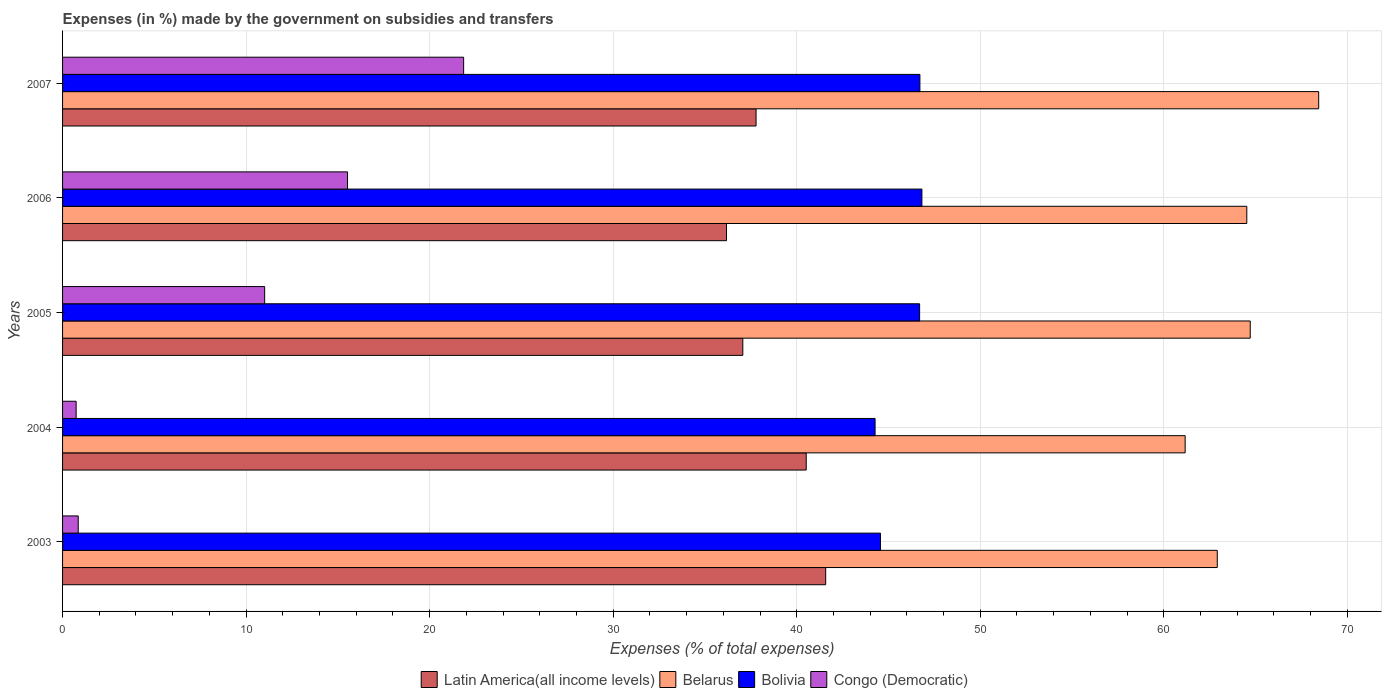How many different coloured bars are there?
Your answer should be compact. 4. How many groups of bars are there?
Your answer should be compact. 5. Are the number of bars on each tick of the Y-axis equal?
Keep it short and to the point. Yes. In how many cases, is the number of bars for a given year not equal to the number of legend labels?
Ensure brevity in your answer.  0. What is the percentage of expenses made by the government on subsidies and transfers in Bolivia in 2005?
Provide a short and direct response. 46.7. Across all years, what is the maximum percentage of expenses made by the government on subsidies and transfers in Bolivia?
Make the answer very short. 46.82. Across all years, what is the minimum percentage of expenses made by the government on subsidies and transfers in Belarus?
Keep it short and to the point. 61.16. In which year was the percentage of expenses made by the government on subsidies and transfers in Congo (Democratic) minimum?
Provide a succinct answer. 2004. What is the total percentage of expenses made by the government on subsidies and transfers in Congo (Democratic) in the graph?
Keep it short and to the point. 49.98. What is the difference between the percentage of expenses made by the government on subsidies and transfers in Congo (Democratic) in 2004 and that in 2006?
Make the answer very short. -14.79. What is the difference between the percentage of expenses made by the government on subsidies and transfers in Belarus in 2006 and the percentage of expenses made by the government on subsidies and transfers in Bolivia in 2003?
Make the answer very short. 19.96. What is the average percentage of expenses made by the government on subsidies and transfers in Belarus per year?
Keep it short and to the point. 64.35. In the year 2003, what is the difference between the percentage of expenses made by the government on subsidies and transfers in Bolivia and percentage of expenses made by the government on subsidies and transfers in Belarus?
Provide a succinct answer. -18.35. In how many years, is the percentage of expenses made by the government on subsidies and transfers in Bolivia greater than 44 %?
Provide a short and direct response. 5. What is the ratio of the percentage of expenses made by the government on subsidies and transfers in Latin America(all income levels) in 2003 to that in 2007?
Give a very brief answer. 1.1. Is the difference between the percentage of expenses made by the government on subsidies and transfers in Bolivia in 2005 and 2006 greater than the difference between the percentage of expenses made by the government on subsidies and transfers in Belarus in 2005 and 2006?
Your answer should be very brief. No. What is the difference between the highest and the second highest percentage of expenses made by the government on subsidies and transfers in Belarus?
Your response must be concise. 3.73. What is the difference between the highest and the lowest percentage of expenses made by the government on subsidies and transfers in Belarus?
Keep it short and to the point. 7.27. In how many years, is the percentage of expenses made by the government on subsidies and transfers in Congo (Democratic) greater than the average percentage of expenses made by the government on subsidies and transfers in Congo (Democratic) taken over all years?
Offer a terse response. 3. Is the sum of the percentage of expenses made by the government on subsidies and transfers in Congo (Democratic) in 2003 and 2007 greater than the maximum percentage of expenses made by the government on subsidies and transfers in Bolivia across all years?
Keep it short and to the point. No. Is it the case that in every year, the sum of the percentage of expenses made by the government on subsidies and transfers in Bolivia and percentage of expenses made by the government on subsidies and transfers in Belarus is greater than the sum of percentage of expenses made by the government on subsidies and transfers in Congo (Democratic) and percentage of expenses made by the government on subsidies and transfers in Latin America(all income levels)?
Offer a very short reply. No. What does the 3rd bar from the bottom in 2007 represents?
Provide a succinct answer. Bolivia. Is it the case that in every year, the sum of the percentage of expenses made by the government on subsidies and transfers in Latin America(all income levels) and percentage of expenses made by the government on subsidies and transfers in Congo (Democratic) is greater than the percentage of expenses made by the government on subsidies and transfers in Bolivia?
Your response must be concise. No. Are the values on the major ticks of X-axis written in scientific E-notation?
Keep it short and to the point. No. Does the graph contain any zero values?
Ensure brevity in your answer.  No. Does the graph contain grids?
Your response must be concise. Yes. Where does the legend appear in the graph?
Provide a short and direct response. Bottom center. How are the legend labels stacked?
Keep it short and to the point. Horizontal. What is the title of the graph?
Make the answer very short. Expenses (in %) made by the government on subsidies and transfers. What is the label or title of the X-axis?
Provide a short and direct response. Expenses (% of total expenses). What is the Expenses (% of total expenses) of Latin America(all income levels) in 2003?
Make the answer very short. 41.58. What is the Expenses (% of total expenses) of Belarus in 2003?
Keep it short and to the point. 62.91. What is the Expenses (% of total expenses) in Bolivia in 2003?
Give a very brief answer. 44.56. What is the Expenses (% of total expenses) of Congo (Democratic) in 2003?
Ensure brevity in your answer.  0.85. What is the Expenses (% of total expenses) in Latin America(all income levels) in 2004?
Your answer should be compact. 40.52. What is the Expenses (% of total expenses) in Belarus in 2004?
Your answer should be compact. 61.16. What is the Expenses (% of total expenses) of Bolivia in 2004?
Offer a terse response. 44.27. What is the Expenses (% of total expenses) in Congo (Democratic) in 2004?
Make the answer very short. 0.74. What is the Expenses (% of total expenses) of Latin America(all income levels) in 2005?
Make the answer very short. 37.06. What is the Expenses (% of total expenses) of Belarus in 2005?
Ensure brevity in your answer.  64.71. What is the Expenses (% of total expenses) in Bolivia in 2005?
Offer a terse response. 46.7. What is the Expenses (% of total expenses) in Congo (Democratic) in 2005?
Offer a very short reply. 11.01. What is the Expenses (% of total expenses) in Latin America(all income levels) in 2006?
Your answer should be very brief. 36.17. What is the Expenses (% of total expenses) of Belarus in 2006?
Make the answer very short. 64.52. What is the Expenses (% of total expenses) of Bolivia in 2006?
Offer a terse response. 46.82. What is the Expenses (% of total expenses) of Congo (Democratic) in 2006?
Ensure brevity in your answer.  15.53. What is the Expenses (% of total expenses) in Latin America(all income levels) in 2007?
Provide a succinct answer. 37.79. What is the Expenses (% of total expenses) of Belarus in 2007?
Offer a terse response. 68.44. What is the Expenses (% of total expenses) in Bolivia in 2007?
Give a very brief answer. 46.71. What is the Expenses (% of total expenses) of Congo (Democratic) in 2007?
Your answer should be very brief. 21.85. Across all years, what is the maximum Expenses (% of total expenses) in Latin America(all income levels)?
Provide a succinct answer. 41.58. Across all years, what is the maximum Expenses (% of total expenses) in Belarus?
Keep it short and to the point. 68.44. Across all years, what is the maximum Expenses (% of total expenses) in Bolivia?
Your answer should be very brief. 46.82. Across all years, what is the maximum Expenses (% of total expenses) of Congo (Democratic)?
Provide a short and direct response. 21.85. Across all years, what is the minimum Expenses (% of total expenses) of Latin America(all income levels)?
Provide a short and direct response. 36.17. Across all years, what is the minimum Expenses (% of total expenses) in Belarus?
Your answer should be very brief. 61.16. Across all years, what is the minimum Expenses (% of total expenses) of Bolivia?
Give a very brief answer. 44.27. Across all years, what is the minimum Expenses (% of total expenses) in Congo (Democratic)?
Your answer should be very brief. 0.74. What is the total Expenses (% of total expenses) in Latin America(all income levels) in the graph?
Give a very brief answer. 193.12. What is the total Expenses (% of total expenses) in Belarus in the graph?
Offer a very short reply. 321.75. What is the total Expenses (% of total expenses) in Bolivia in the graph?
Provide a short and direct response. 229.06. What is the total Expenses (% of total expenses) in Congo (Democratic) in the graph?
Offer a terse response. 49.98. What is the difference between the Expenses (% of total expenses) in Latin America(all income levels) in 2003 and that in 2004?
Give a very brief answer. 1.06. What is the difference between the Expenses (% of total expenses) of Belarus in 2003 and that in 2004?
Offer a terse response. 1.75. What is the difference between the Expenses (% of total expenses) of Bolivia in 2003 and that in 2004?
Your answer should be compact. 0.29. What is the difference between the Expenses (% of total expenses) of Congo (Democratic) in 2003 and that in 2004?
Offer a very short reply. 0.11. What is the difference between the Expenses (% of total expenses) in Latin America(all income levels) in 2003 and that in 2005?
Provide a succinct answer. 4.52. What is the difference between the Expenses (% of total expenses) in Belarus in 2003 and that in 2005?
Keep it short and to the point. -1.8. What is the difference between the Expenses (% of total expenses) of Bolivia in 2003 and that in 2005?
Make the answer very short. -2.13. What is the difference between the Expenses (% of total expenses) in Congo (Democratic) in 2003 and that in 2005?
Ensure brevity in your answer.  -10.16. What is the difference between the Expenses (% of total expenses) of Latin America(all income levels) in 2003 and that in 2006?
Your answer should be compact. 5.4. What is the difference between the Expenses (% of total expenses) of Belarus in 2003 and that in 2006?
Provide a short and direct response. -1.61. What is the difference between the Expenses (% of total expenses) in Bolivia in 2003 and that in 2006?
Give a very brief answer. -2.26. What is the difference between the Expenses (% of total expenses) of Congo (Democratic) in 2003 and that in 2006?
Keep it short and to the point. -14.67. What is the difference between the Expenses (% of total expenses) of Latin America(all income levels) in 2003 and that in 2007?
Your answer should be very brief. 3.79. What is the difference between the Expenses (% of total expenses) of Belarus in 2003 and that in 2007?
Provide a succinct answer. -5.52. What is the difference between the Expenses (% of total expenses) of Bolivia in 2003 and that in 2007?
Give a very brief answer. -2.15. What is the difference between the Expenses (% of total expenses) in Congo (Democratic) in 2003 and that in 2007?
Keep it short and to the point. -21. What is the difference between the Expenses (% of total expenses) of Latin America(all income levels) in 2004 and that in 2005?
Provide a succinct answer. 3.46. What is the difference between the Expenses (% of total expenses) of Belarus in 2004 and that in 2005?
Offer a very short reply. -3.55. What is the difference between the Expenses (% of total expenses) in Bolivia in 2004 and that in 2005?
Make the answer very short. -2.43. What is the difference between the Expenses (% of total expenses) in Congo (Democratic) in 2004 and that in 2005?
Provide a succinct answer. -10.27. What is the difference between the Expenses (% of total expenses) in Latin America(all income levels) in 2004 and that in 2006?
Ensure brevity in your answer.  4.34. What is the difference between the Expenses (% of total expenses) in Belarus in 2004 and that in 2006?
Give a very brief answer. -3.36. What is the difference between the Expenses (% of total expenses) in Bolivia in 2004 and that in 2006?
Your response must be concise. -2.55. What is the difference between the Expenses (% of total expenses) in Congo (Democratic) in 2004 and that in 2006?
Give a very brief answer. -14.79. What is the difference between the Expenses (% of total expenses) of Latin America(all income levels) in 2004 and that in 2007?
Keep it short and to the point. 2.73. What is the difference between the Expenses (% of total expenses) in Belarus in 2004 and that in 2007?
Your answer should be very brief. -7.28. What is the difference between the Expenses (% of total expenses) in Bolivia in 2004 and that in 2007?
Keep it short and to the point. -2.44. What is the difference between the Expenses (% of total expenses) of Congo (Democratic) in 2004 and that in 2007?
Your answer should be very brief. -21.11. What is the difference between the Expenses (% of total expenses) of Latin America(all income levels) in 2005 and that in 2006?
Offer a very short reply. 0.89. What is the difference between the Expenses (% of total expenses) of Belarus in 2005 and that in 2006?
Keep it short and to the point. 0.19. What is the difference between the Expenses (% of total expenses) of Bolivia in 2005 and that in 2006?
Provide a succinct answer. -0.12. What is the difference between the Expenses (% of total expenses) in Congo (Democratic) in 2005 and that in 2006?
Your response must be concise. -4.51. What is the difference between the Expenses (% of total expenses) in Latin America(all income levels) in 2005 and that in 2007?
Your answer should be very brief. -0.72. What is the difference between the Expenses (% of total expenses) in Belarus in 2005 and that in 2007?
Provide a short and direct response. -3.73. What is the difference between the Expenses (% of total expenses) in Bolivia in 2005 and that in 2007?
Your answer should be compact. -0.02. What is the difference between the Expenses (% of total expenses) of Congo (Democratic) in 2005 and that in 2007?
Your answer should be very brief. -10.84. What is the difference between the Expenses (% of total expenses) of Latin America(all income levels) in 2006 and that in 2007?
Your answer should be compact. -1.61. What is the difference between the Expenses (% of total expenses) in Belarus in 2006 and that in 2007?
Keep it short and to the point. -3.92. What is the difference between the Expenses (% of total expenses) of Bolivia in 2006 and that in 2007?
Give a very brief answer. 0.11. What is the difference between the Expenses (% of total expenses) in Congo (Democratic) in 2006 and that in 2007?
Your answer should be very brief. -6.33. What is the difference between the Expenses (% of total expenses) of Latin America(all income levels) in 2003 and the Expenses (% of total expenses) of Belarus in 2004?
Your response must be concise. -19.59. What is the difference between the Expenses (% of total expenses) in Latin America(all income levels) in 2003 and the Expenses (% of total expenses) in Bolivia in 2004?
Offer a very short reply. -2.69. What is the difference between the Expenses (% of total expenses) in Latin America(all income levels) in 2003 and the Expenses (% of total expenses) in Congo (Democratic) in 2004?
Your answer should be very brief. 40.84. What is the difference between the Expenses (% of total expenses) in Belarus in 2003 and the Expenses (% of total expenses) in Bolivia in 2004?
Ensure brevity in your answer.  18.65. What is the difference between the Expenses (% of total expenses) of Belarus in 2003 and the Expenses (% of total expenses) of Congo (Democratic) in 2004?
Keep it short and to the point. 62.17. What is the difference between the Expenses (% of total expenses) of Bolivia in 2003 and the Expenses (% of total expenses) of Congo (Democratic) in 2004?
Ensure brevity in your answer.  43.82. What is the difference between the Expenses (% of total expenses) in Latin America(all income levels) in 2003 and the Expenses (% of total expenses) in Belarus in 2005?
Offer a very short reply. -23.13. What is the difference between the Expenses (% of total expenses) of Latin America(all income levels) in 2003 and the Expenses (% of total expenses) of Bolivia in 2005?
Your answer should be compact. -5.12. What is the difference between the Expenses (% of total expenses) in Latin America(all income levels) in 2003 and the Expenses (% of total expenses) in Congo (Democratic) in 2005?
Your answer should be very brief. 30.57. What is the difference between the Expenses (% of total expenses) in Belarus in 2003 and the Expenses (% of total expenses) in Bolivia in 2005?
Make the answer very short. 16.22. What is the difference between the Expenses (% of total expenses) of Belarus in 2003 and the Expenses (% of total expenses) of Congo (Democratic) in 2005?
Provide a succinct answer. 51.9. What is the difference between the Expenses (% of total expenses) in Bolivia in 2003 and the Expenses (% of total expenses) in Congo (Democratic) in 2005?
Provide a short and direct response. 33.55. What is the difference between the Expenses (% of total expenses) in Latin America(all income levels) in 2003 and the Expenses (% of total expenses) in Belarus in 2006?
Provide a succinct answer. -22.94. What is the difference between the Expenses (% of total expenses) in Latin America(all income levels) in 2003 and the Expenses (% of total expenses) in Bolivia in 2006?
Your response must be concise. -5.24. What is the difference between the Expenses (% of total expenses) in Latin America(all income levels) in 2003 and the Expenses (% of total expenses) in Congo (Democratic) in 2006?
Offer a very short reply. 26.05. What is the difference between the Expenses (% of total expenses) of Belarus in 2003 and the Expenses (% of total expenses) of Bolivia in 2006?
Keep it short and to the point. 16.09. What is the difference between the Expenses (% of total expenses) of Belarus in 2003 and the Expenses (% of total expenses) of Congo (Democratic) in 2006?
Your answer should be very brief. 47.39. What is the difference between the Expenses (% of total expenses) of Bolivia in 2003 and the Expenses (% of total expenses) of Congo (Democratic) in 2006?
Provide a succinct answer. 29.04. What is the difference between the Expenses (% of total expenses) in Latin America(all income levels) in 2003 and the Expenses (% of total expenses) in Belarus in 2007?
Your answer should be compact. -26.86. What is the difference between the Expenses (% of total expenses) of Latin America(all income levels) in 2003 and the Expenses (% of total expenses) of Bolivia in 2007?
Offer a very short reply. -5.13. What is the difference between the Expenses (% of total expenses) of Latin America(all income levels) in 2003 and the Expenses (% of total expenses) of Congo (Democratic) in 2007?
Your response must be concise. 19.73. What is the difference between the Expenses (% of total expenses) of Belarus in 2003 and the Expenses (% of total expenses) of Bolivia in 2007?
Ensure brevity in your answer.  16.2. What is the difference between the Expenses (% of total expenses) in Belarus in 2003 and the Expenses (% of total expenses) in Congo (Democratic) in 2007?
Your answer should be very brief. 41.06. What is the difference between the Expenses (% of total expenses) of Bolivia in 2003 and the Expenses (% of total expenses) of Congo (Democratic) in 2007?
Your answer should be very brief. 22.71. What is the difference between the Expenses (% of total expenses) of Latin America(all income levels) in 2004 and the Expenses (% of total expenses) of Belarus in 2005?
Your response must be concise. -24.19. What is the difference between the Expenses (% of total expenses) in Latin America(all income levels) in 2004 and the Expenses (% of total expenses) in Bolivia in 2005?
Offer a terse response. -6.18. What is the difference between the Expenses (% of total expenses) of Latin America(all income levels) in 2004 and the Expenses (% of total expenses) of Congo (Democratic) in 2005?
Give a very brief answer. 29.51. What is the difference between the Expenses (% of total expenses) of Belarus in 2004 and the Expenses (% of total expenses) of Bolivia in 2005?
Provide a short and direct response. 14.47. What is the difference between the Expenses (% of total expenses) of Belarus in 2004 and the Expenses (% of total expenses) of Congo (Democratic) in 2005?
Ensure brevity in your answer.  50.15. What is the difference between the Expenses (% of total expenses) of Bolivia in 2004 and the Expenses (% of total expenses) of Congo (Democratic) in 2005?
Your answer should be compact. 33.26. What is the difference between the Expenses (% of total expenses) in Latin America(all income levels) in 2004 and the Expenses (% of total expenses) in Belarus in 2006?
Your response must be concise. -24. What is the difference between the Expenses (% of total expenses) of Latin America(all income levels) in 2004 and the Expenses (% of total expenses) of Bolivia in 2006?
Your response must be concise. -6.3. What is the difference between the Expenses (% of total expenses) of Latin America(all income levels) in 2004 and the Expenses (% of total expenses) of Congo (Democratic) in 2006?
Your answer should be very brief. 24.99. What is the difference between the Expenses (% of total expenses) in Belarus in 2004 and the Expenses (% of total expenses) in Bolivia in 2006?
Offer a terse response. 14.34. What is the difference between the Expenses (% of total expenses) in Belarus in 2004 and the Expenses (% of total expenses) in Congo (Democratic) in 2006?
Provide a succinct answer. 45.64. What is the difference between the Expenses (% of total expenses) of Bolivia in 2004 and the Expenses (% of total expenses) of Congo (Democratic) in 2006?
Provide a short and direct response. 28.74. What is the difference between the Expenses (% of total expenses) in Latin America(all income levels) in 2004 and the Expenses (% of total expenses) in Belarus in 2007?
Your answer should be very brief. -27.92. What is the difference between the Expenses (% of total expenses) in Latin America(all income levels) in 2004 and the Expenses (% of total expenses) in Bolivia in 2007?
Your answer should be compact. -6.19. What is the difference between the Expenses (% of total expenses) of Latin America(all income levels) in 2004 and the Expenses (% of total expenses) of Congo (Democratic) in 2007?
Provide a succinct answer. 18.66. What is the difference between the Expenses (% of total expenses) in Belarus in 2004 and the Expenses (% of total expenses) in Bolivia in 2007?
Your answer should be very brief. 14.45. What is the difference between the Expenses (% of total expenses) of Belarus in 2004 and the Expenses (% of total expenses) of Congo (Democratic) in 2007?
Provide a succinct answer. 39.31. What is the difference between the Expenses (% of total expenses) of Bolivia in 2004 and the Expenses (% of total expenses) of Congo (Democratic) in 2007?
Give a very brief answer. 22.42. What is the difference between the Expenses (% of total expenses) of Latin America(all income levels) in 2005 and the Expenses (% of total expenses) of Belarus in 2006?
Ensure brevity in your answer.  -27.46. What is the difference between the Expenses (% of total expenses) of Latin America(all income levels) in 2005 and the Expenses (% of total expenses) of Bolivia in 2006?
Your answer should be very brief. -9.76. What is the difference between the Expenses (% of total expenses) in Latin America(all income levels) in 2005 and the Expenses (% of total expenses) in Congo (Democratic) in 2006?
Offer a terse response. 21.54. What is the difference between the Expenses (% of total expenses) of Belarus in 2005 and the Expenses (% of total expenses) of Bolivia in 2006?
Your answer should be compact. 17.89. What is the difference between the Expenses (% of total expenses) in Belarus in 2005 and the Expenses (% of total expenses) in Congo (Democratic) in 2006?
Give a very brief answer. 49.18. What is the difference between the Expenses (% of total expenses) in Bolivia in 2005 and the Expenses (% of total expenses) in Congo (Democratic) in 2006?
Your answer should be very brief. 31.17. What is the difference between the Expenses (% of total expenses) in Latin America(all income levels) in 2005 and the Expenses (% of total expenses) in Belarus in 2007?
Offer a very short reply. -31.38. What is the difference between the Expenses (% of total expenses) of Latin America(all income levels) in 2005 and the Expenses (% of total expenses) of Bolivia in 2007?
Offer a very short reply. -9.65. What is the difference between the Expenses (% of total expenses) in Latin America(all income levels) in 2005 and the Expenses (% of total expenses) in Congo (Democratic) in 2007?
Provide a short and direct response. 15.21. What is the difference between the Expenses (% of total expenses) of Belarus in 2005 and the Expenses (% of total expenses) of Bolivia in 2007?
Keep it short and to the point. 18. What is the difference between the Expenses (% of total expenses) in Belarus in 2005 and the Expenses (% of total expenses) in Congo (Democratic) in 2007?
Offer a terse response. 42.86. What is the difference between the Expenses (% of total expenses) of Bolivia in 2005 and the Expenses (% of total expenses) of Congo (Democratic) in 2007?
Your answer should be very brief. 24.84. What is the difference between the Expenses (% of total expenses) of Latin America(all income levels) in 2006 and the Expenses (% of total expenses) of Belarus in 2007?
Offer a terse response. -32.26. What is the difference between the Expenses (% of total expenses) of Latin America(all income levels) in 2006 and the Expenses (% of total expenses) of Bolivia in 2007?
Give a very brief answer. -10.54. What is the difference between the Expenses (% of total expenses) in Latin America(all income levels) in 2006 and the Expenses (% of total expenses) in Congo (Democratic) in 2007?
Offer a terse response. 14.32. What is the difference between the Expenses (% of total expenses) in Belarus in 2006 and the Expenses (% of total expenses) in Bolivia in 2007?
Keep it short and to the point. 17.81. What is the difference between the Expenses (% of total expenses) of Belarus in 2006 and the Expenses (% of total expenses) of Congo (Democratic) in 2007?
Provide a succinct answer. 42.67. What is the difference between the Expenses (% of total expenses) of Bolivia in 2006 and the Expenses (% of total expenses) of Congo (Democratic) in 2007?
Offer a very short reply. 24.97. What is the average Expenses (% of total expenses) in Latin America(all income levels) per year?
Provide a succinct answer. 38.62. What is the average Expenses (% of total expenses) of Belarus per year?
Keep it short and to the point. 64.35. What is the average Expenses (% of total expenses) of Bolivia per year?
Provide a succinct answer. 45.81. What is the average Expenses (% of total expenses) of Congo (Democratic) per year?
Offer a terse response. 10. In the year 2003, what is the difference between the Expenses (% of total expenses) of Latin America(all income levels) and Expenses (% of total expenses) of Belarus?
Make the answer very short. -21.34. In the year 2003, what is the difference between the Expenses (% of total expenses) of Latin America(all income levels) and Expenses (% of total expenses) of Bolivia?
Offer a very short reply. -2.99. In the year 2003, what is the difference between the Expenses (% of total expenses) in Latin America(all income levels) and Expenses (% of total expenses) in Congo (Democratic)?
Provide a succinct answer. 40.72. In the year 2003, what is the difference between the Expenses (% of total expenses) in Belarus and Expenses (% of total expenses) in Bolivia?
Offer a very short reply. 18.35. In the year 2003, what is the difference between the Expenses (% of total expenses) in Belarus and Expenses (% of total expenses) in Congo (Democratic)?
Provide a short and direct response. 62.06. In the year 2003, what is the difference between the Expenses (% of total expenses) in Bolivia and Expenses (% of total expenses) in Congo (Democratic)?
Offer a terse response. 43.71. In the year 2004, what is the difference between the Expenses (% of total expenses) in Latin America(all income levels) and Expenses (% of total expenses) in Belarus?
Offer a terse response. -20.65. In the year 2004, what is the difference between the Expenses (% of total expenses) of Latin America(all income levels) and Expenses (% of total expenses) of Bolivia?
Your answer should be very brief. -3.75. In the year 2004, what is the difference between the Expenses (% of total expenses) of Latin America(all income levels) and Expenses (% of total expenses) of Congo (Democratic)?
Your answer should be very brief. 39.78. In the year 2004, what is the difference between the Expenses (% of total expenses) in Belarus and Expenses (% of total expenses) in Bolivia?
Offer a terse response. 16.89. In the year 2004, what is the difference between the Expenses (% of total expenses) in Belarus and Expenses (% of total expenses) in Congo (Democratic)?
Your answer should be very brief. 60.42. In the year 2004, what is the difference between the Expenses (% of total expenses) in Bolivia and Expenses (% of total expenses) in Congo (Democratic)?
Provide a succinct answer. 43.53. In the year 2005, what is the difference between the Expenses (% of total expenses) of Latin America(all income levels) and Expenses (% of total expenses) of Belarus?
Provide a succinct answer. -27.65. In the year 2005, what is the difference between the Expenses (% of total expenses) in Latin America(all income levels) and Expenses (% of total expenses) in Bolivia?
Your answer should be very brief. -9.63. In the year 2005, what is the difference between the Expenses (% of total expenses) of Latin America(all income levels) and Expenses (% of total expenses) of Congo (Democratic)?
Your answer should be compact. 26.05. In the year 2005, what is the difference between the Expenses (% of total expenses) in Belarus and Expenses (% of total expenses) in Bolivia?
Keep it short and to the point. 18.01. In the year 2005, what is the difference between the Expenses (% of total expenses) of Belarus and Expenses (% of total expenses) of Congo (Democratic)?
Provide a succinct answer. 53.7. In the year 2005, what is the difference between the Expenses (% of total expenses) in Bolivia and Expenses (% of total expenses) in Congo (Democratic)?
Your answer should be compact. 35.69. In the year 2006, what is the difference between the Expenses (% of total expenses) in Latin America(all income levels) and Expenses (% of total expenses) in Belarus?
Offer a very short reply. -28.35. In the year 2006, what is the difference between the Expenses (% of total expenses) of Latin America(all income levels) and Expenses (% of total expenses) of Bolivia?
Offer a very short reply. -10.65. In the year 2006, what is the difference between the Expenses (% of total expenses) in Latin America(all income levels) and Expenses (% of total expenses) in Congo (Democratic)?
Keep it short and to the point. 20.65. In the year 2006, what is the difference between the Expenses (% of total expenses) in Belarus and Expenses (% of total expenses) in Bolivia?
Make the answer very short. 17.7. In the year 2006, what is the difference between the Expenses (% of total expenses) of Belarus and Expenses (% of total expenses) of Congo (Democratic)?
Make the answer very short. 49. In the year 2006, what is the difference between the Expenses (% of total expenses) of Bolivia and Expenses (% of total expenses) of Congo (Democratic)?
Offer a very short reply. 31.3. In the year 2007, what is the difference between the Expenses (% of total expenses) of Latin America(all income levels) and Expenses (% of total expenses) of Belarus?
Offer a very short reply. -30.65. In the year 2007, what is the difference between the Expenses (% of total expenses) of Latin America(all income levels) and Expenses (% of total expenses) of Bolivia?
Keep it short and to the point. -8.93. In the year 2007, what is the difference between the Expenses (% of total expenses) of Latin America(all income levels) and Expenses (% of total expenses) of Congo (Democratic)?
Provide a succinct answer. 15.93. In the year 2007, what is the difference between the Expenses (% of total expenses) of Belarus and Expenses (% of total expenses) of Bolivia?
Offer a terse response. 21.73. In the year 2007, what is the difference between the Expenses (% of total expenses) in Belarus and Expenses (% of total expenses) in Congo (Democratic)?
Make the answer very short. 46.59. In the year 2007, what is the difference between the Expenses (% of total expenses) in Bolivia and Expenses (% of total expenses) in Congo (Democratic)?
Your response must be concise. 24.86. What is the ratio of the Expenses (% of total expenses) of Latin America(all income levels) in 2003 to that in 2004?
Ensure brevity in your answer.  1.03. What is the ratio of the Expenses (% of total expenses) in Belarus in 2003 to that in 2004?
Your response must be concise. 1.03. What is the ratio of the Expenses (% of total expenses) in Bolivia in 2003 to that in 2004?
Offer a very short reply. 1.01. What is the ratio of the Expenses (% of total expenses) of Congo (Democratic) in 2003 to that in 2004?
Offer a terse response. 1.15. What is the ratio of the Expenses (% of total expenses) of Latin America(all income levels) in 2003 to that in 2005?
Your answer should be compact. 1.12. What is the ratio of the Expenses (% of total expenses) in Belarus in 2003 to that in 2005?
Your response must be concise. 0.97. What is the ratio of the Expenses (% of total expenses) of Bolivia in 2003 to that in 2005?
Your answer should be very brief. 0.95. What is the ratio of the Expenses (% of total expenses) of Congo (Democratic) in 2003 to that in 2005?
Give a very brief answer. 0.08. What is the ratio of the Expenses (% of total expenses) of Latin America(all income levels) in 2003 to that in 2006?
Your answer should be very brief. 1.15. What is the ratio of the Expenses (% of total expenses) in Belarus in 2003 to that in 2006?
Your response must be concise. 0.98. What is the ratio of the Expenses (% of total expenses) in Bolivia in 2003 to that in 2006?
Your response must be concise. 0.95. What is the ratio of the Expenses (% of total expenses) in Congo (Democratic) in 2003 to that in 2006?
Your response must be concise. 0.06. What is the ratio of the Expenses (% of total expenses) in Latin America(all income levels) in 2003 to that in 2007?
Offer a very short reply. 1.1. What is the ratio of the Expenses (% of total expenses) in Belarus in 2003 to that in 2007?
Your answer should be very brief. 0.92. What is the ratio of the Expenses (% of total expenses) in Bolivia in 2003 to that in 2007?
Ensure brevity in your answer.  0.95. What is the ratio of the Expenses (% of total expenses) in Congo (Democratic) in 2003 to that in 2007?
Offer a very short reply. 0.04. What is the ratio of the Expenses (% of total expenses) of Latin America(all income levels) in 2004 to that in 2005?
Provide a succinct answer. 1.09. What is the ratio of the Expenses (% of total expenses) of Belarus in 2004 to that in 2005?
Your answer should be very brief. 0.95. What is the ratio of the Expenses (% of total expenses) in Bolivia in 2004 to that in 2005?
Keep it short and to the point. 0.95. What is the ratio of the Expenses (% of total expenses) of Congo (Democratic) in 2004 to that in 2005?
Ensure brevity in your answer.  0.07. What is the ratio of the Expenses (% of total expenses) in Latin America(all income levels) in 2004 to that in 2006?
Provide a succinct answer. 1.12. What is the ratio of the Expenses (% of total expenses) in Belarus in 2004 to that in 2006?
Your response must be concise. 0.95. What is the ratio of the Expenses (% of total expenses) of Bolivia in 2004 to that in 2006?
Ensure brevity in your answer.  0.95. What is the ratio of the Expenses (% of total expenses) in Congo (Democratic) in 2004 to that in 2006?
Provide a succinct answer. 0.05. What is the ratio of the Expenses (% of total expenses) in Latin America(all income levels) in 2004 to that in 2007?
Offer a very short reply. 1.07. What is the ratio of the Expenses (% of total expenses) of Belarus in 2004 to that in 2007?
Provide a succinct answer. 0.89. What is the ratio of the Expenses (% of total expenses) in Bolivia in 2004 to that in 2007?
Provide a succinct answer. 0.95. What is the ratio of the Expenses (% of total expenses) in Congo (Democratic) in 2004 to that in 2007?
Offer a terse response. 0.03. What is the ratio of the Expenses (% of total expenses) of Latin America(all income levels) in 2005 to that in 2006?
Ensure brevity in your answer.  1.02. What is the ratio of the Expenses (% of total expenses) of Congo (Democratic) in 2005 to that in 2006?
Keep it short and to the point. 0.71. What is the ratio of the Expenses (% of total expenses) of Latin America(all income levels) in 2005 to that in 2007?
Offer a very short reply. 0.98. What is the ratio of the Expenses (% of total expenses) of Belarus in 2005 to that in 2007?
Your answer should be compact. 0.95. What is the ratio of the Expenses (% of total expenses) in Congo (Democratic) in 2005 to that in 2007?
Keep it short and to the point. 0.5. What is the ratio of the Expenses (% of total expenses) of Latin America(all income levels) in 2006 to that in 2007?
Ensure brevity in your answer.  0.96. What is the ratio of the Expenses (% of total expenses) of Belarus in 2006 to that in 2007?
Provide a succinct answer. 0.94. What is the ratio of the Expenses (% of total expenses) of Bolivia in 2006 to that in 2007?
Your answer should be very brief. 1. What is the ratio of the Expenses (% of total expenses) of Congo (Democratic) in 2006 to that in 2007?
Your answer should be compact. 0.71. What is the difference between the highest and the second highest Expenses (% of total expenses) of Latin America(all income levels)?
Offer a terse response. 1.06. What is the difference between the highest and the second highest Expenses (% of total expenses) in Belarus?
Offer a terse response. 3.73. What is the difference between the highest and the second highest Expenses (% of total expenses) in Bolivia?
Provide a succinct answer. 0.11. What is the difference between the highest and the second highest Expenses (% of total expenses) of Congo (Democratic)?
Give a very brief answer. 6.33. What is the difference between the highest and the lowest Expenses (% of total expenses) in Latin America(all income levels)?
Offer a very short reply. 5.4. What is the difference between the highest and the lowest Expenses (% of total expenses) of Belarus?
Your response must be concise. 7.28. What is the difference between the highest and the lowest Expenses (% of total expenses) in Bolivia?
Offer a very short reply. 2.55. What is the difference between the highest and the lowest Expenses (% of total expenses) in Congo (Democratic)?
Offer a terse response. 21.11. 